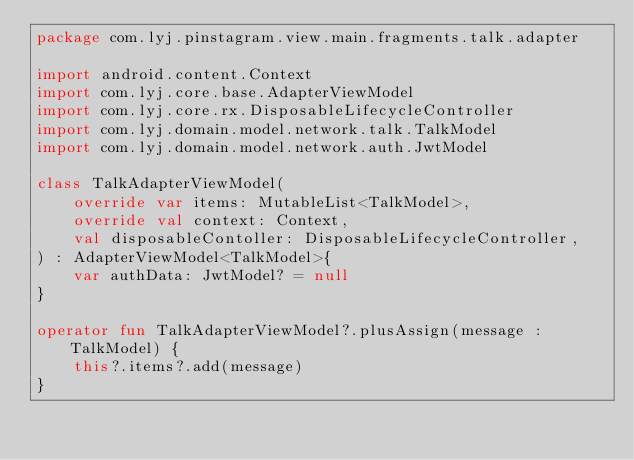Convert code to text. <code><loc_0><loc_0><loc_500><loc_500><_Kotlin_>package com.lyj.pinstagram.view.main.fragments.talk.adapter

import android.content.Context
import com.lyj.core.base.AdapterViewModel
import com.lyj.core.rx.DisposableLifecycleController
import com.lyj.domain.model.network.talk.TalkModel
import com.lyj.domain.model.network.auth.JwtModel

class TalkAdapterViewModel(
    override var items: MutableList<TalkModel>,
    override val context: Context,
    val disposableContoller: DisposableLifecycleController,
) : AdapterViewModel<TalkModel>{
    var authData: JwtModel? = null
}

operator fun TalkAdapterViewModel?.plusAssign(message : TalkModel) {
    this?.items?.add(message)
}</code> 